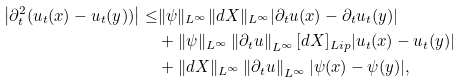<formula> <loc_0><loc_0><loc_500><loc_500>\left | \partial _ { t } ^ { 2 } ( u _ { t } ( x ) - u _ { t } ( y ) ) \right | \leq & \| \psi \| _ { L ^ { \infty } } \| d X \| _ { L ^ { \infty } } | \partial _ { t } u ( x ) - \partial _ { t } u _ { t } ( y ) | \\ & + \| \psi \| _ { L ^ { \infty } } \left \| \partial _ { t } u \right \| _ { L ^ { \infty } } [ d X ] _ { L i p } | u _ { t } ( x ) - u _ { t } ( y ) | \\ & + \| d X \| _ { L ^ { \infty } } \left \| \partial _ { t } u \right \| _ { L ^ { \infty } } | \psi ( x ) - \psi ( y ) | ,</formula> 